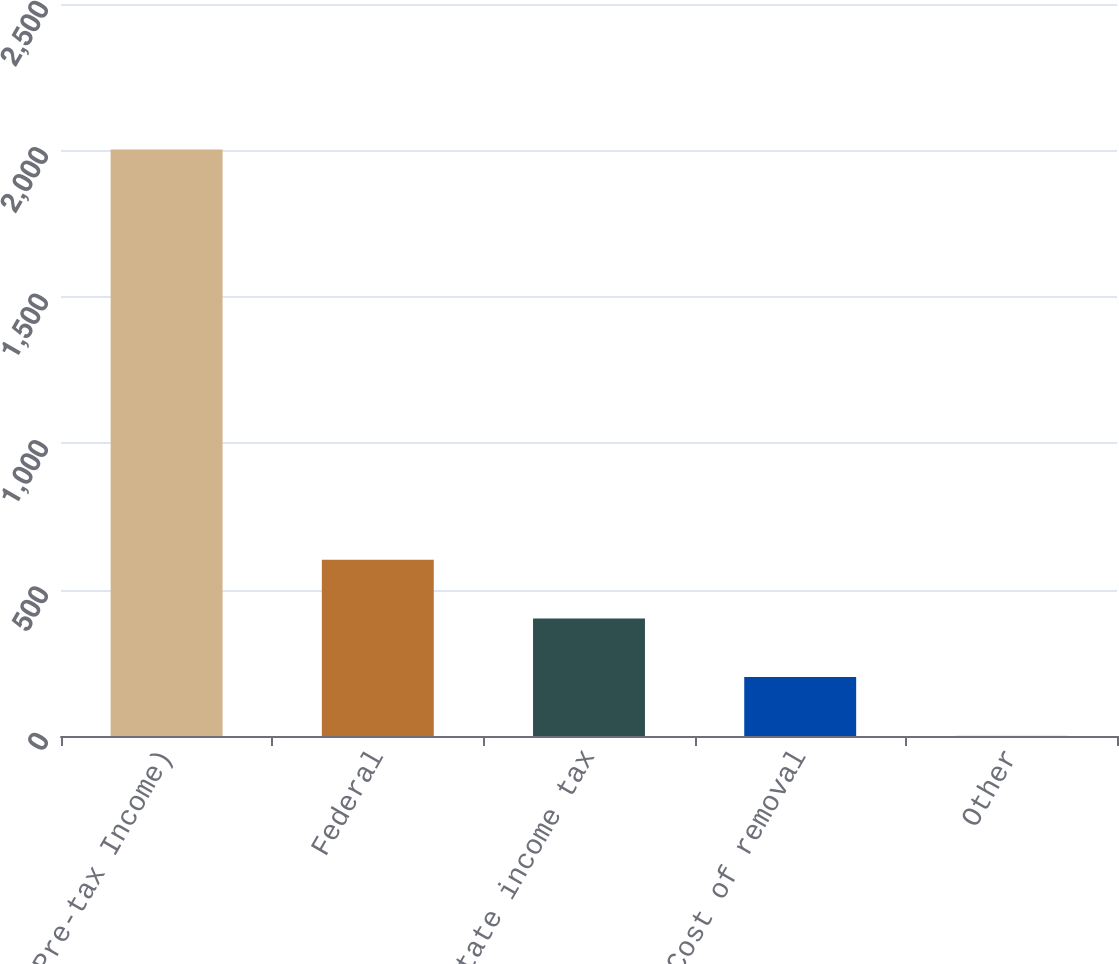<chart> <loc_0><loc_0><loc_500><loc_500><bar_chart><fcel>( of Pre-tax Income)<fcel>Federal<fcel>State income tax<fcel>Cost of removal<fcel>Other<nl><fcel>2003<fcel>601.6<fcel>401.4<fcel>201.2<fcel>1<nl></chart> 